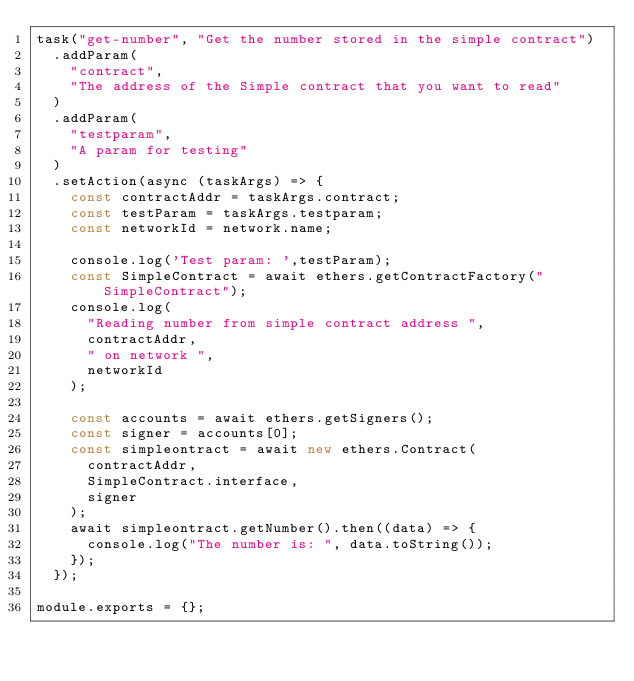Convert code to text. <code><loc_0><loc_0><loc_500><loc_500><_JavaScript_>task("get-number", "Get the number stored in the simple contract")
  .addParam(
    "contract",
    "The address of the Simple contract that you want to read"
  )
  .addParam(
    "testparam",
    "A param for testing"
  )
  .setAction(async (taskArgs) => {
    const contractAddr = taskArgs.contract;
    const testParam = taskArgs.testparam;
    const networkId = network.name;

    console.log('Test param: ',testParam);
    const SimpleContract = await ethers.getContractFactory("SimpleContract");
    console.log(
      "Reading number from simple contract address ",
      contractAddr,
      " on network ",
      networkId
    );

    const accounts = await ethers.getSigners();
    const signer = accounts[0];
    const simpleontract = await new ethers.Contract(
      contractAddr,
      SimpleContract.interface,
      signer
    );
    await simpleontract.getNumber().then((data) => {
      console.log("The number is: ", data.toString());
    });
  });

module.exports = {};
</code> 